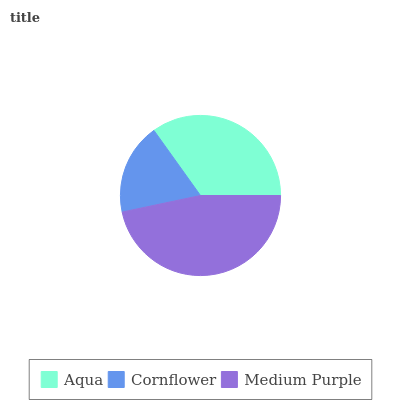Is Cornflower the minimum?
Answer yes or no. Yes. Is Medium Purple the maximum?
Answer yes or no. Yes. Is Medium Purple the minimum?
Answer yes or no. No. Is Cornflower the maximum?
Answer yes or no. No. Is Medium Purple greater than Cornflower?
Answer yes or no. Yes. Is Cornflower less than Medium Purple?
Answer yes or no. Yes. Is Cornflower greater than Medium Purple?
Answer yes or no. No. Is Medium Purple less than Cornflower?
Answer yes or no. No. Is Aqua the high median?
Answer yes or no. Yes. Is Aqua the low median?
Answer yes or no. Yes. Is Medium Purple the high median?
Answer yes or no. No. Is Medium Purple the low median?
Answer yes or no. No. 